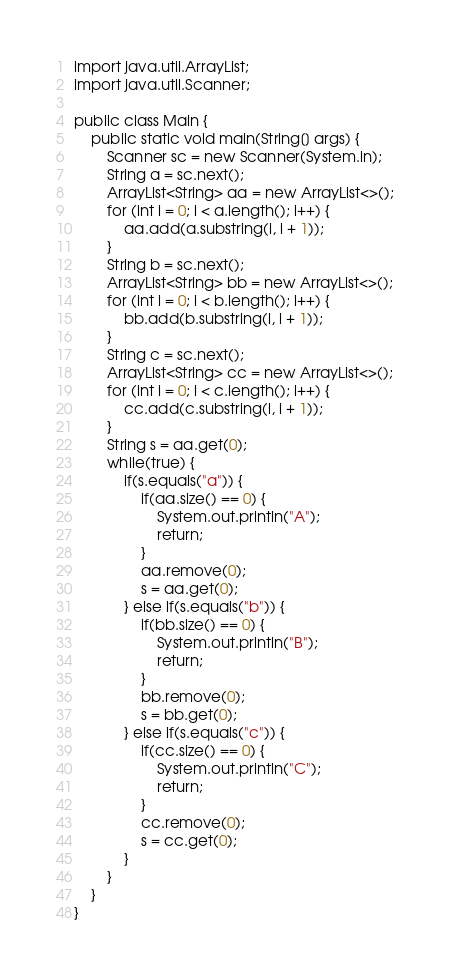Convert code to text. <code><loc_0><loc_0><loc_500><loc_500><_Java_>import java.util.ArrayList;
import java.util.Scanner;

public class Main {
    public static void main(String[] args) {
        Scanner sc = new Scanner(System.in);
        String a = sc.next();
        ArrayList<String> aa = new ArrayList<>();
        for (int i = 0; i < a.length(); i++) {
            aa.add(a.substring(i, i + 1));
        }
        String b = sc.next();
        ArrayList<String> bb = new ArrayList<>();
        for (int i = 0; i < b.length(); i++) {
            bb.add(b.substring(i, i + 1));
        }
        String c = sc.next();
        ArrayList<String> cc = new ArrayList<>();
        for (int i = 0; i < c.length(); i++) {
            cc.add(c.substring(i, i + 1));
        }
        String s = aa.get(0);
        while(true) {
            if(s.equals("a")) {
                if(aa.size() == 0) {
                    System.out.println("A");
                    return;
                }
                aa.remove(0);
                s = aa.get(0);
            } else if(s.equals("b")) {
                if(bb.size() == 0) {
                    System.out.println("B");
                    return;
                }
                bb.remove(0);
                s = bb.get(0);
            } else if(s.equals("c")) {
                if(cc.size() == 0) {
                    System.out.println("C");
                    return;
                }
                cc.remove(0);
                s = cc.get(0);
            }
        }
    }
}</code> 